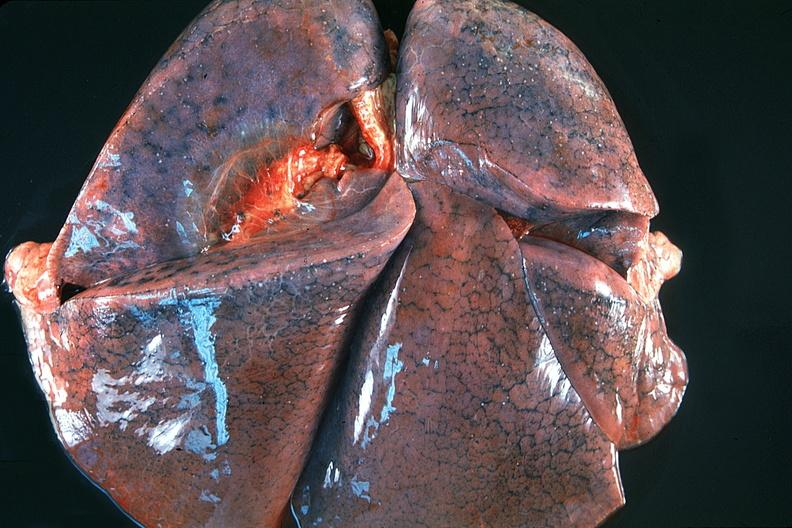does this image show normal lung?
Answer the question using a single word or phrase. Yes 